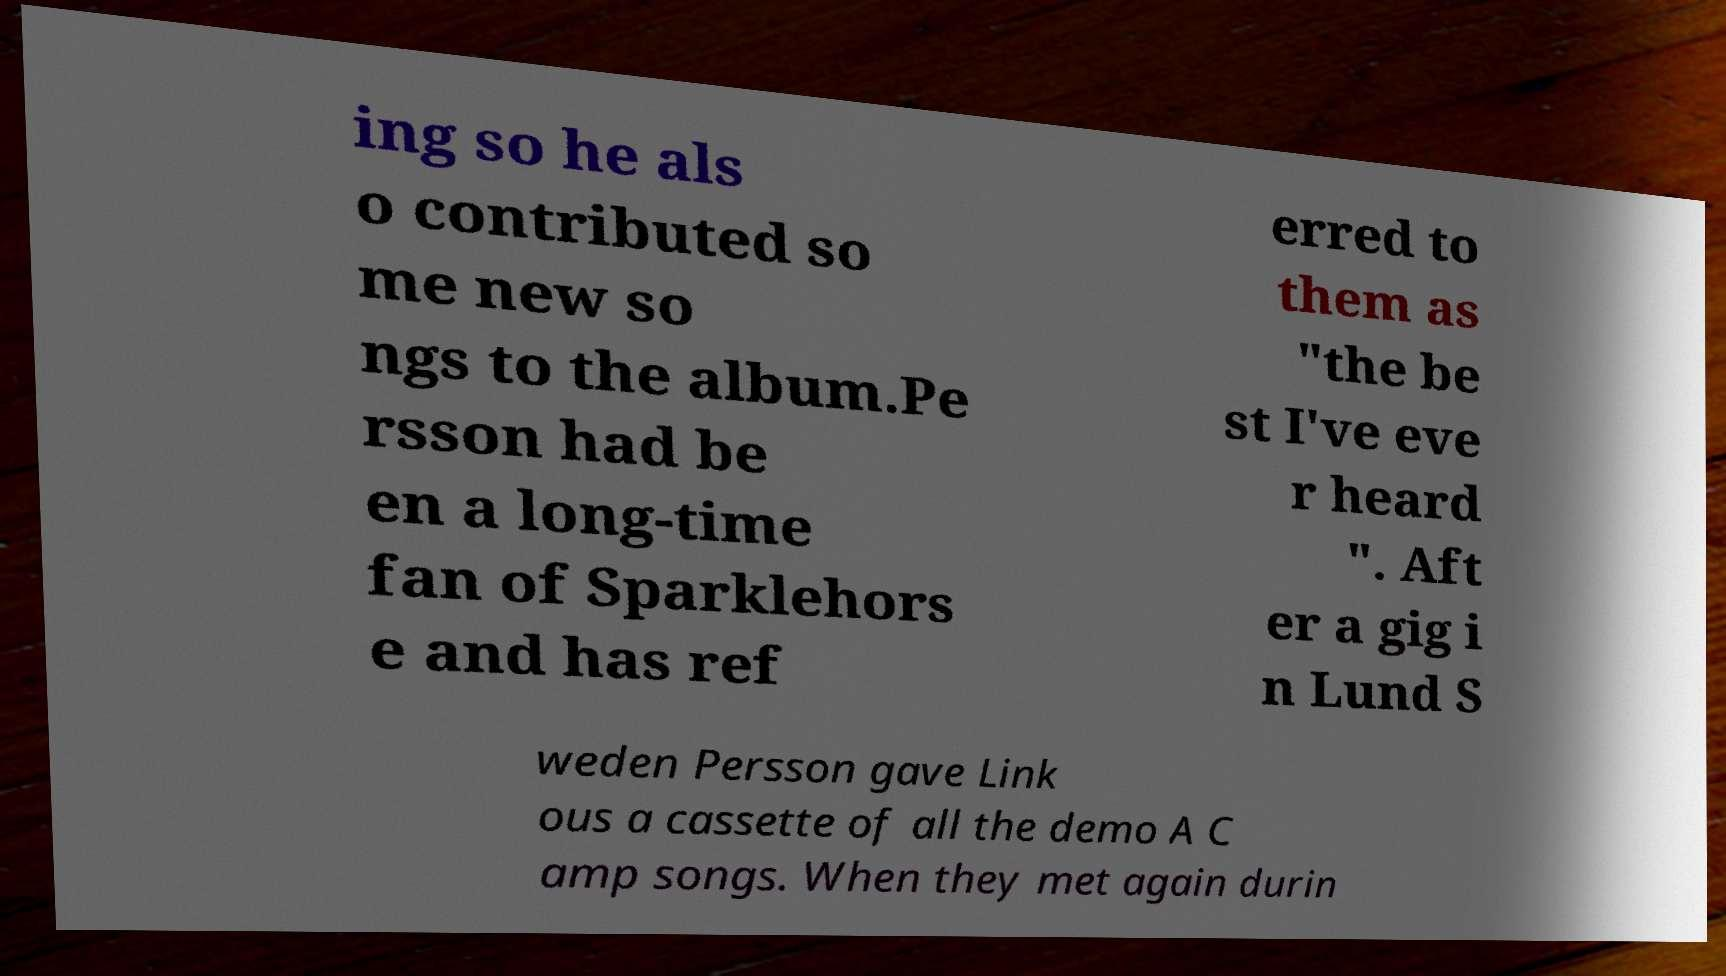What messages or text are displayed in this image? I need them in a readable, typed format. ing so he als o contributed so me new so ngs to the album.Pe rsson had be en a long-time fan of Sparklehors e and has ref erred to them as "the be st I've eve r heard ". Aft er a gig i n Lund S weden Persson gave Link ous a cassette of all the demo A C amp songs. When they met again durin 